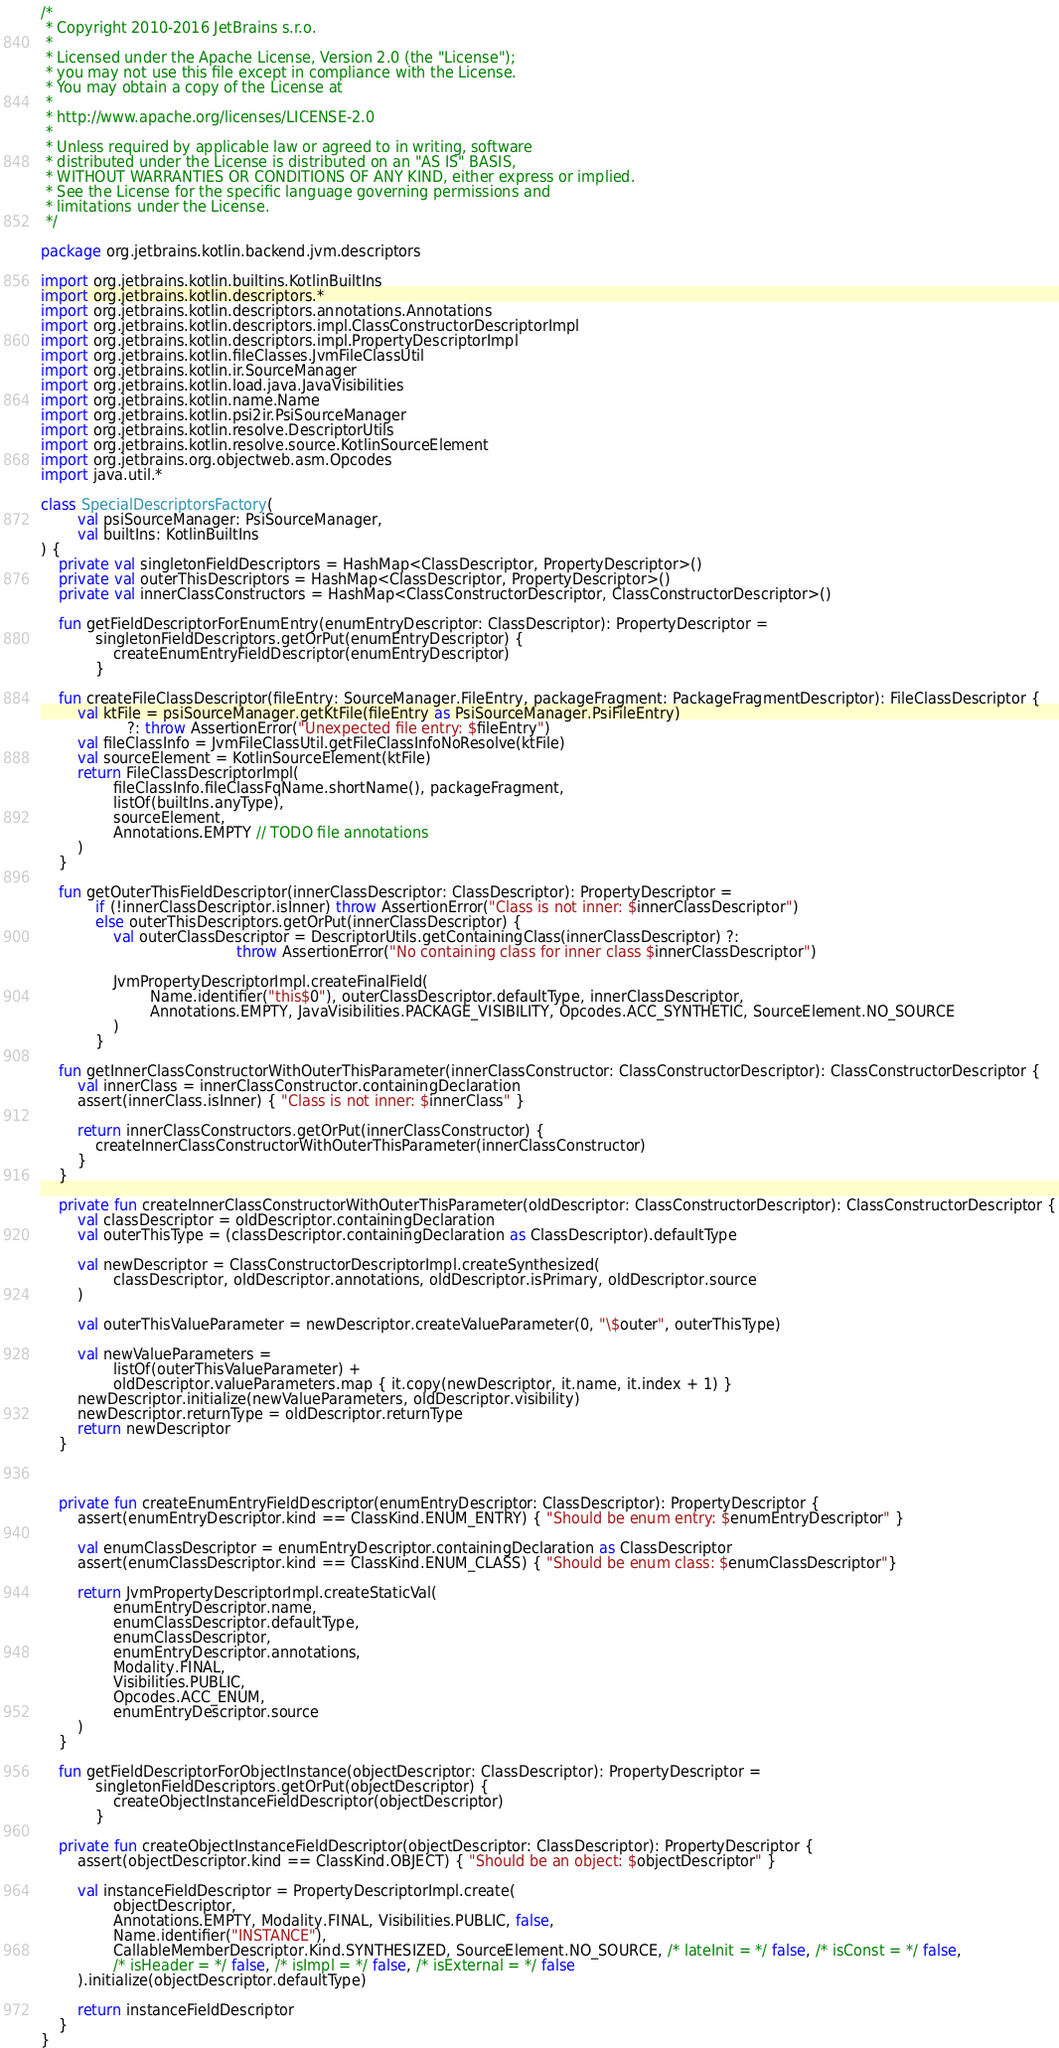<code> <loc_0><loc_0><loc_500><loc_500><_Kotlin_>/*
 * Copyright 2010-2016 JetBrains s.r.o.
 *
 * Licensed under the Apache License, Version 2.0 (the "License");
 * you may not use this file except in compliance with the License.
 * You may obtain a copy of the License at
 *
 * http://www.apache.org/licenses/LICENSE-2.0
 *
 * Unless required by applicable law or agreed to in writing, software
 * distributed under the License is distributed on an "AS IS" BASIS,
 * WITHOUT WARRANTIES OR CONDITIONS OF ANY KIND, either express or implied.
 * See the License for the specific language governing permissions and
 * limitations under the License.
 */

package org.jetbrains.kotlin.backend.jvm.descriptors

import org.jetbrains.kotlin.builtins.KotlinBuiltIns
import org.jetbrains.kotlin.descriptors.*
import org.jetbrains.kotlin.descriptors.annotations.Annotations
import org.jetbrains.kotlin.descriptors.impl.ClassConstructorDescriptorImpl
import org.jetbrains.kotlin.descriptors.impl.PropertyDescriptorImpl
import org.jetbrains.kotlin.fileClasses.JvmFileClassUtil
import org.jetbrains.kotlin.ir.SourceManager
import org.jetbrains.kotlin.load.java.JavaVisibilities
import org.jetbrains.kotlin.name.Name
import org.jetbrains.kotlin.psi2ir.PsiSourceManager
import org.jetbrains.kotlin.resolve.DescriptorUtils
import org.jetbrains.kotlin.resolve.source.KotlinSourceElement
import org.jetbrains.org.objectweb.asm.Opcodes
import java.util.*

class SpecialDescriptorsFactory(
        val psiSourceManager: PsiSourceManager,
        val builtIns: KotlinBuiltIns
) {
    private val singletonFieldDescriptors = HashMap<ClassDescriptor, PropertyDescriptor>()
    private val outerThisDescriptors = HashMap<ClassDescriptor, PropertyDescriptor>()
    private val innerClassConstructors = HashMap<ClassConstructorDescriptor, ClassConstructorDescriptor>()

    fun getFieldDescriptorForEnumEntry(enumEntryDescriptor: ClassDescriptor): PropertyDescriptor =
            singletonFieldDescriptors.getOrPut(enumEntryDescriptor) {
                createEnumEntryFieldDescriptor(enumEntryDescriptor)
            }

    fun createFileClassDescriptor(fileEntry: SourceManager.FileEntry, packageFragment: PackageFragmentDescriptor): FileClassDescriptor {
        val ktFile = psiSourceManager.getKtFile(fileEntry as PsiSourceManager.PsiFileEntry)
                   ?: throw AssertionError("Unexpected file entry: $fileEntry")
        val fileClassInfo = JvmFileClassUtil.getFileClassInfoNoResolve(ktFile)
        val sourceElement = KotlinSourceElement(ktFile)
        return FileClassDescriptorImpl(
                fileClassInfo.fileClassFqName.shortName(), packageFragment,
                listOf(builtIns.anyType),
                sourceElement,
                Annotations.EMPTY // TODO file annotations
        )
    }

    fun getOuterThisFieldDescriptor(innerClassDescriptor: ClassDescriptor): PropertyDescriptor =
            if (!innerClassDescriptor.isInner) throw AssertionError("Class is not inner: $innerClassDescriptor")
            else outerThisDescriptors.getOrPut(innerClassDescriptor) {
                val outerClassDescriptor = DescriptorUtils.getContainingClass(innerClassDescriptor) ?:
                                           throw AssertionError("No containing class for inner class $innerClassDescriptor")

                JvmPropertyDescriptorImpl.createFinalField(
                        Name.identifier("this$0"), outerClassDescriptor.defaultType, innerClassDescriptor,
                        Annotations.EMPTY, JavaVisibilities.PACKAGE_VISIBILITY, Opcodes.ACC_SYNTHETIC, SourceElement.NO_SOURCE
                )
            }

    fun getInnerClassConstructorWithOuterThisParameter(innerClassConstructor: ClassConstructorDescriptor): ClassConstructorDescriptor {
        val innerClass = innerClassConstructor.containingDeclaration
        assert(innerClass.isInner) { "Class is not inner: $innerClass" }

        return innerClassConstructors.getOrPut(innerClassConstructor) {
            createInnerClassConstructorWithOuterThisParameter(innerClassConstructor)
        }
    }

    private fun createInnerClassConstructorWithOuterThisParameter(oldDescriptor: ClassConstructorDescriptor): ClassConstructorDescriptor {
        val classDescriptor = oldDescriptor.containingDeclaration
        val outerThisType = (classDescriptor.containingDeclaration as ClassDescriptor).defaultType

        val newDescriptor = ClassConstructorDescriptorImpl.createSynthesized(
                classDescriptor, oldDescriptor.annotations, oldDescriptor.isPrimary, oldDescriptor.source
        )

        val outerThisValueParameter = newDescriptor.createValueParameter(0, "\$outer", outerThisType)

        val newValueParameters =
                listOf(outerThisValueParameter) +
                oldDescriptor.valueParameters.map { it.copy(newDescriptor, it.name, it.index + 1) }
        newDescriptor.initialize(newValueParameters, oldDescriptor.visibility)
        newDescriptor.returnType = oldDescriptor.returnType
        return newDescriptor
    }



    private fun createEnumEntryFieldDescriptor(enumEntryDescriptor: ClassDescriptor): PropertyDescriptor {
        assert(enumEntryDescriptor.kind == ClassKind.ENUM_ENTRY) { "Should be enum entry: $enumEntryDescriptor" }

        val enumClassDescriptor = enumEntryDescriptor.containingDeclaration as ClassDescriptor
        assert(enumClassDescriptor.kind == ClassKind.ENUM_CLASS) { "Should be enum class: $enumClassDescriptor"}

        return JvmPropertyDescriptorImpl.createStaticVal(
                enumEntryDescriptor.name,
                enumClassDescriptor.defaultType,
                enumClassDescriptor,
                enumEntryDescriptor.annotations,
                Modality.FINAL,
                Visibilities.PUBLIC,
                Opcodes.ACC_ENUM,
                enumEntryDescriptor.source
        )
    }

    fun getFieldDescriptorForObjectInstance(objectDescriptor: ClassDescriptor): PropertyDescriptor =
            singletonFieldDescriptors.getOrPut(objectDescriptor) {
                createObjectInstanceFieldDescriptor(objectDescriptor)
            }

    private fun createObjectInstanceFieldDescriptor(objectDescriptor: ClassDescriptor): PropertyDescriptor {
        assert(objectDescriptor.kind == ClassKind.OBJECT) { "Should be an object: $objectDescriptor" }

        val instanceFieldDescriptor = PropertyDescriptorImpl.create(
                objectDescriptor,
                Annotations.EMPTY, Modality.FINAL, Visibilities.PUBLIC, false,
                Name.identifier("INSTANCE"),
                CallableMemberDescriptor.Kind.SYNTHESIZED, SourceElement.NO_SOURCE, /* lateInit = */ false, /* isConst = */ false,
                /* isHeader = */ false, /* isImpl = */ false, /* isExternal = */ false
        ).initialize(objectDescriptor.defaultType)

        return instanceFieldDescriptor
    }
}</code> 